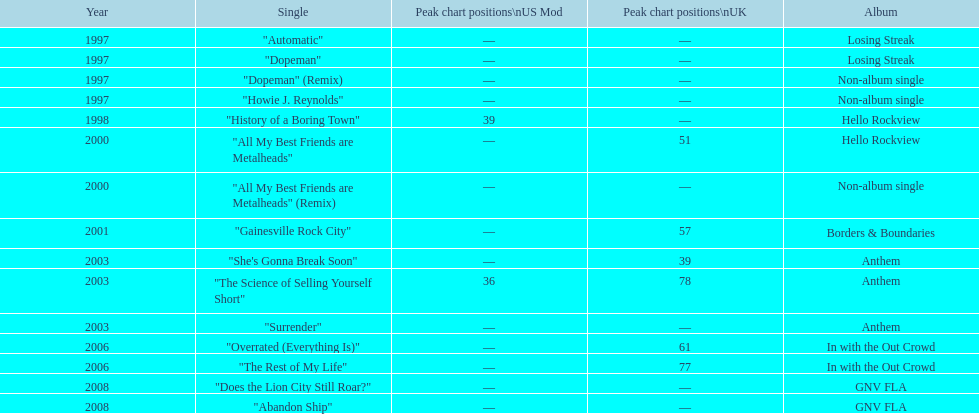In which album was the single "automatic" featured? Losing Streak. 